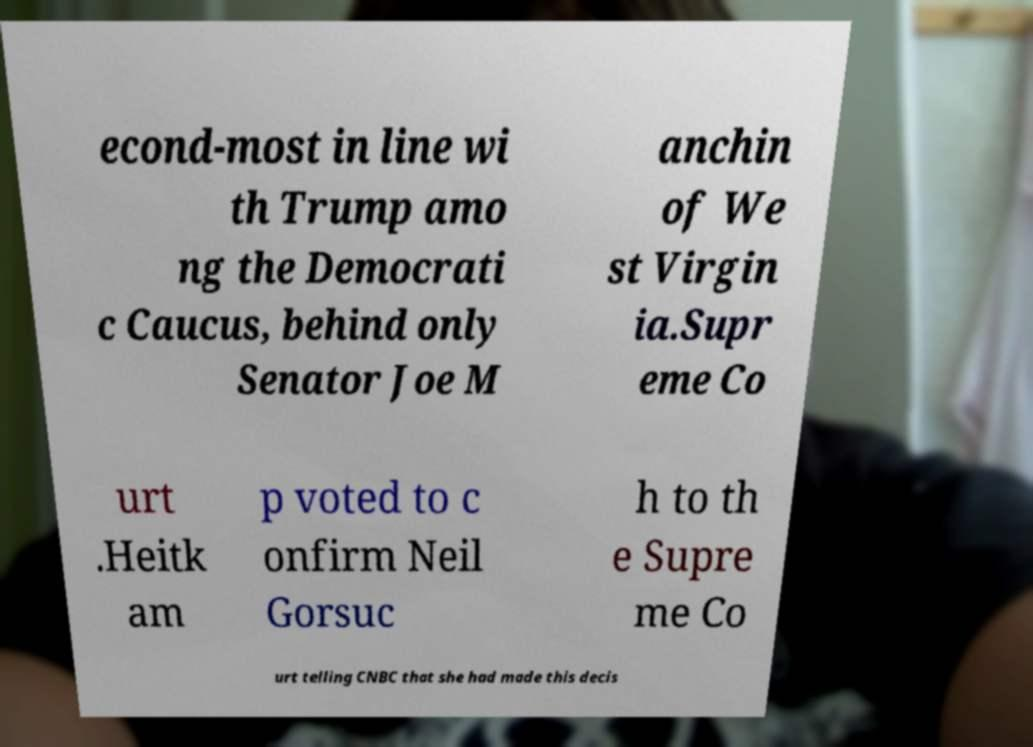Could you assist in decoding the text presented in this image and type it out clearly? econd-most in line wi th Trump amo ng the Democrati c Caucus, behind only Senator Joe M anchin of We st Virgin ia.Supr eme Co urt .Heitk am p voted to c onfirm Neil Gorsuc h to th e Supre me Co urt telling CNBC that she had made this decis 